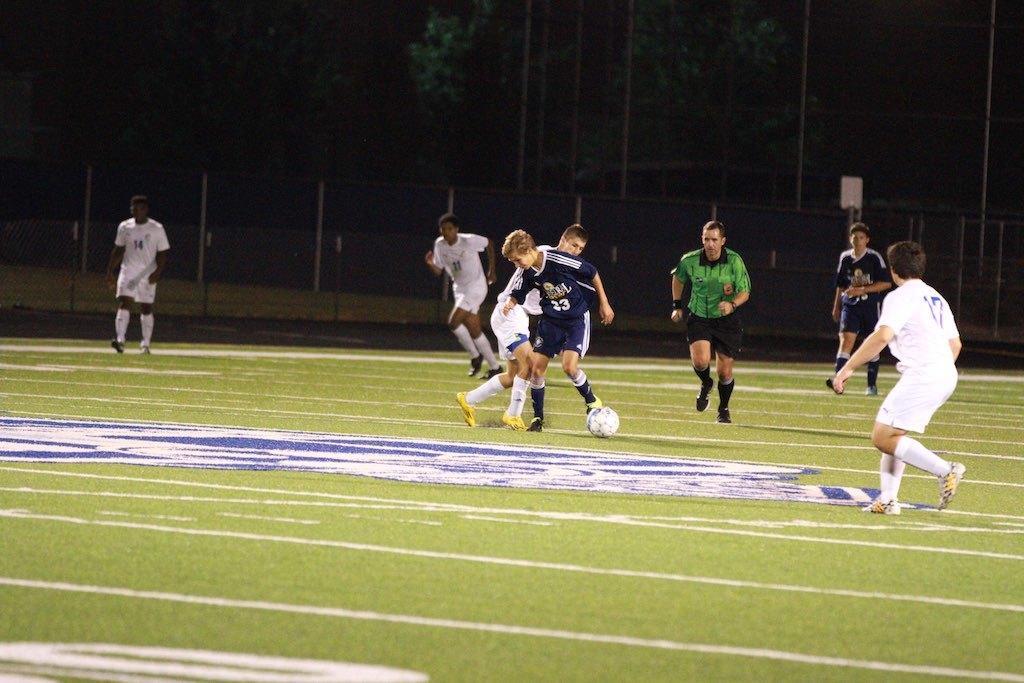Can you describe this image briefly? This picture shows a group of men playing football on a green field and we see trees around 